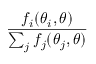Convert formula to latex. <formula><loc_0><loc_0><loc_500><loc_500>\frac { f _ { i } ( \theta _ { i } , \theta ) } { \sum _ { j } f _ { j } ( \theta _ { j } , \theta ) }</formula> 